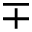<formula> <loc_0><loc_0><loc_500><loc_500>\mp</formula> 